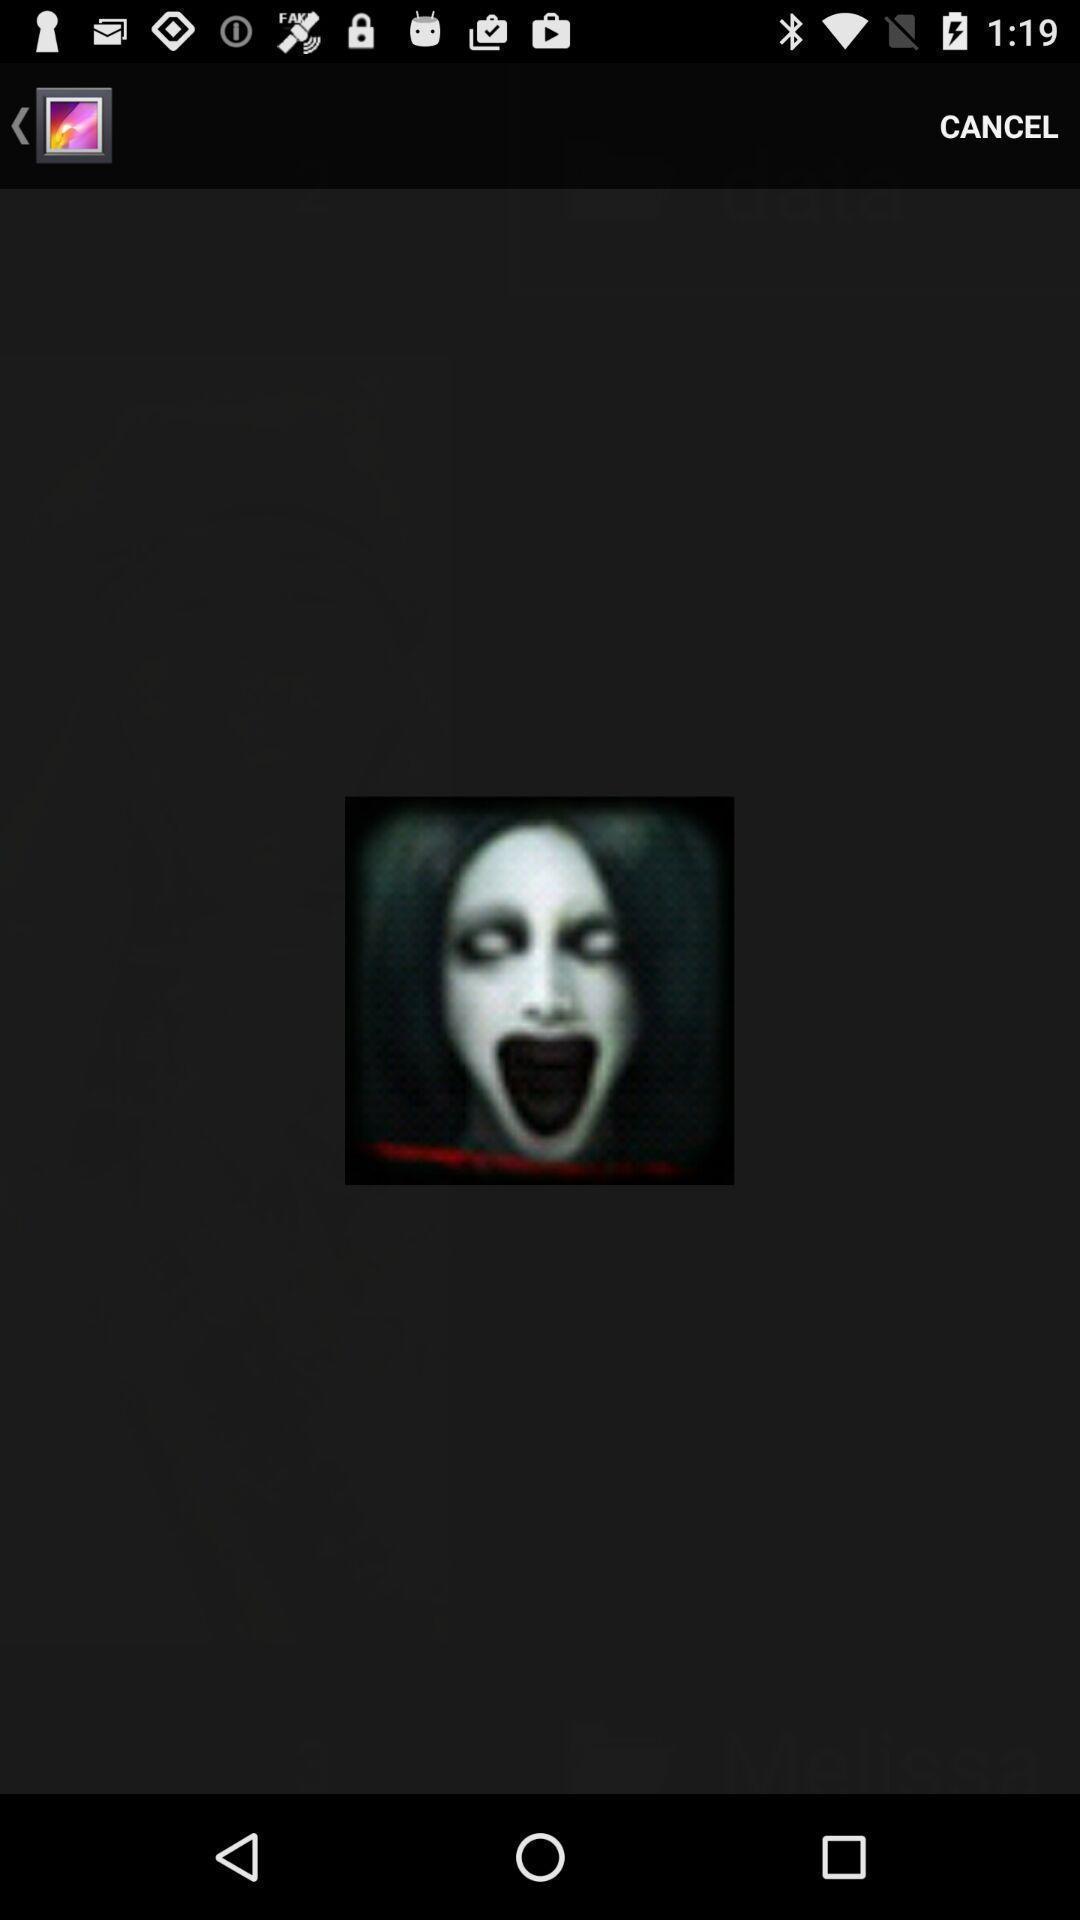Tell me what you see in this picture. Screen displaying a picture in the gallery. 